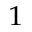Convert formula to latex. <formula><loc_0><loc_0><loc_500><loc_500>^ { 1 }</formula> 